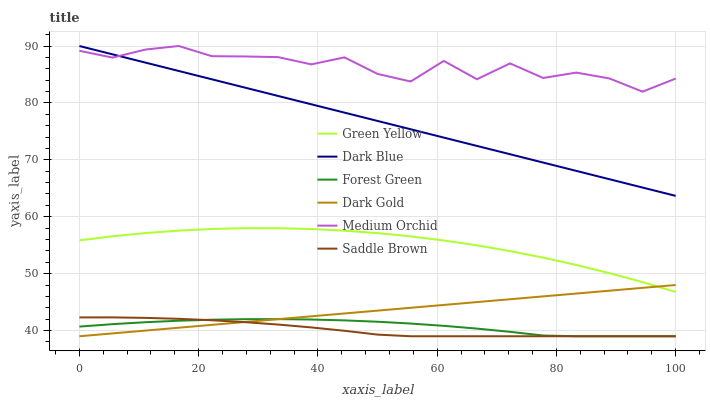Does Saddle Brown have the minimum area under the curve?
Answer yes or no. Yes. Does Medium Orchid have the maximum area under the curve?
Answer yes or no. Yes. Does Dark Blue have the minimum area under the curve?
Answer yes or no. No. Does Dark Blue have the maximum area under the curve?
Answer yes or no. No. Is Dark Gold the smoothest?
Answer yes or no. Yes. Is Medium Orchid the roughest?
Answer yes or no. Yes. Is Dark Blue the smoothest?
Answer yes or no. No. Is Dark Blue the roughest?
Answer yes or no. No. Does Dark Gold have the lowest value?
Answer yes or no. Yes. Does Dark Blue have the lowest value?
Answer yes or no. No. Does Dark Blue have the highest value?
Answer yes or no. Yes. Does Forest Green have the highest value?
Answer yes or no. No. Is Saddle Brown less than Dark Blue?
Answer yes or no. Yes. Is Dark Blue greater than Saddle Brown?
Answer yes or no. Yes. Does Forest Green intersect Dark Gold?
Answer yes or no. Yes. Is Forest Green less than Dark Gold?
Answer yes or no. No. Is Forest Green greater than Dark Gold?
Answer yes or no. No. Does Saddle Brown intersect Dark Blue?
Answer yes or no. No. 